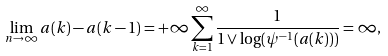Convert formula to latex. <formula><loc_0><loc_0><loc_500><loc_500>\lim _ { n \rightarrow \infty } a ( k ) - a ( k - 1 ) = + \infty \sum _ { k = 1 } ^ { \infty } \frac { 1 } { 1 \vee \log ( \psi ^ { - 1 } ( a ( k ) ) ) } = \infty ,</formula> 